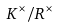Convert formula to latex. <formula><loc_0><loc_0><loc_500><loc_500>K ^ { \times } / R ^ { \times }</formula> 